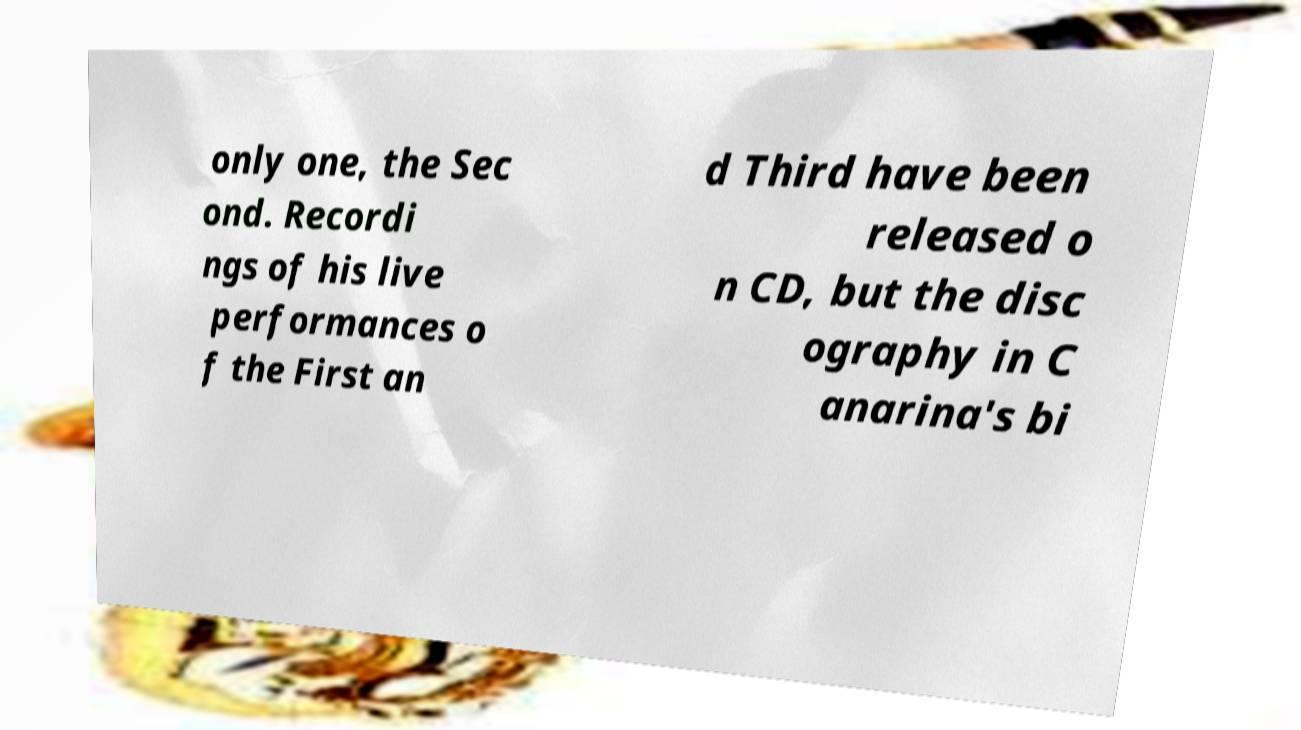Please read and relay the text visible in this image. What does it say? only one, the Sec ond. Recordi ngs of his live performances o f the First an d Third have been released o n CD, but the disc ography in C anarina's bi 